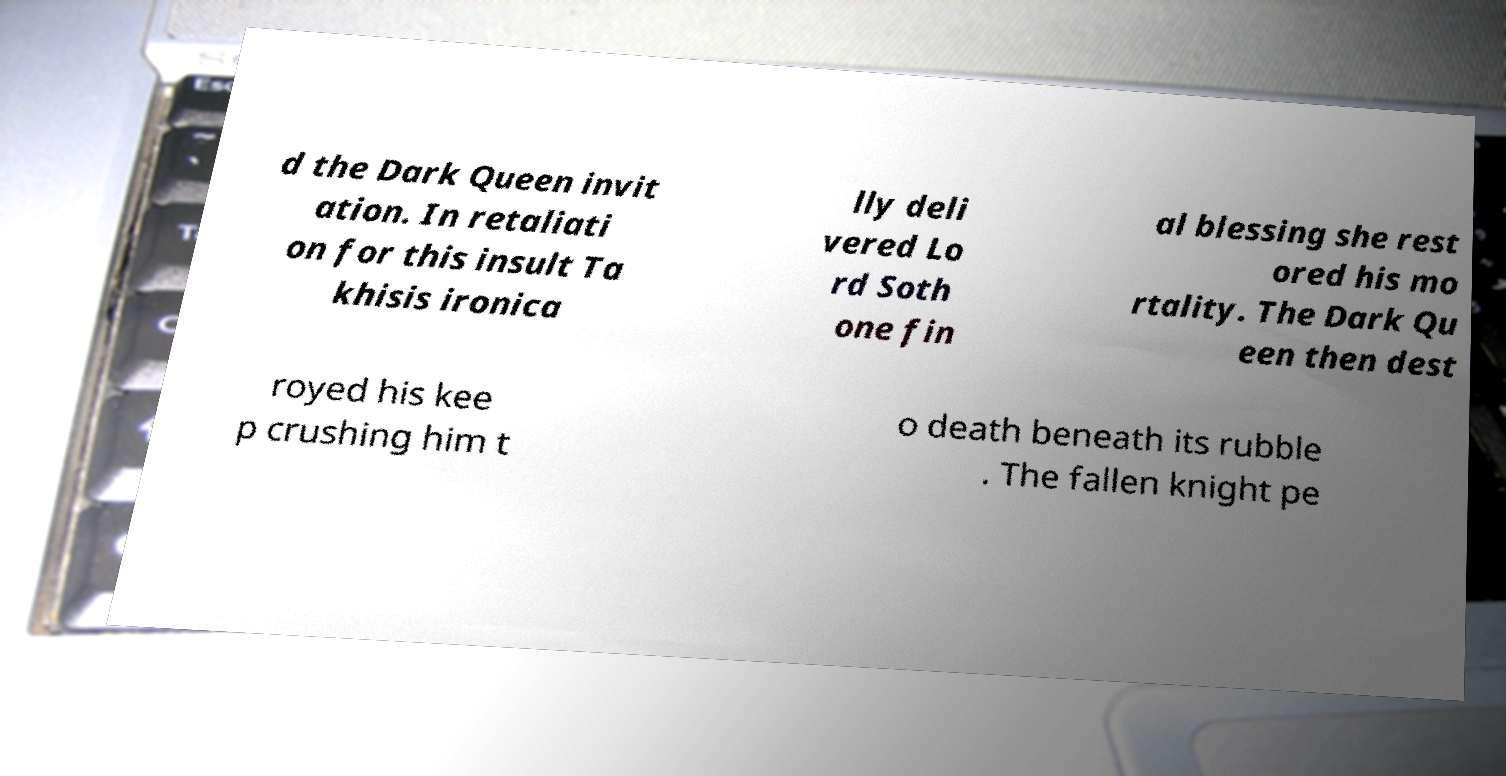For documentation purposes, I need the text within this image transcribed. Could you provide that? d the Dark Queen invit ation. In retaliati on for this insult Ta khisis ironica lly deli vered Lo rd Soth one fin al blessing she rest ored his mo rtality. The Dark Qu een then dest royed his kee p crushing him t o death beneath its rubble . The fallen knight pe 